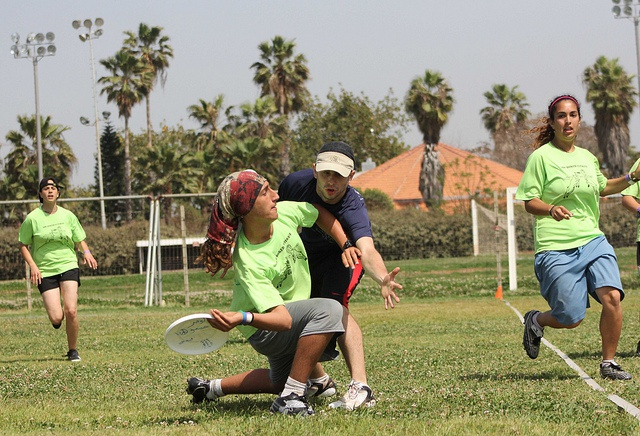Describe the objects in this image and their specific colors. I can see people in lightgray, black, khaki, maroon, and olive tones, people in lightgray, khaki, black, and olive tones, people in lightgray, black, gray, tan, and olive tones, people in lightgray, khaki, olive, black, and tan tones, and frisbee in lightgray, olive, darkgray, gray, and white tones in this image. 